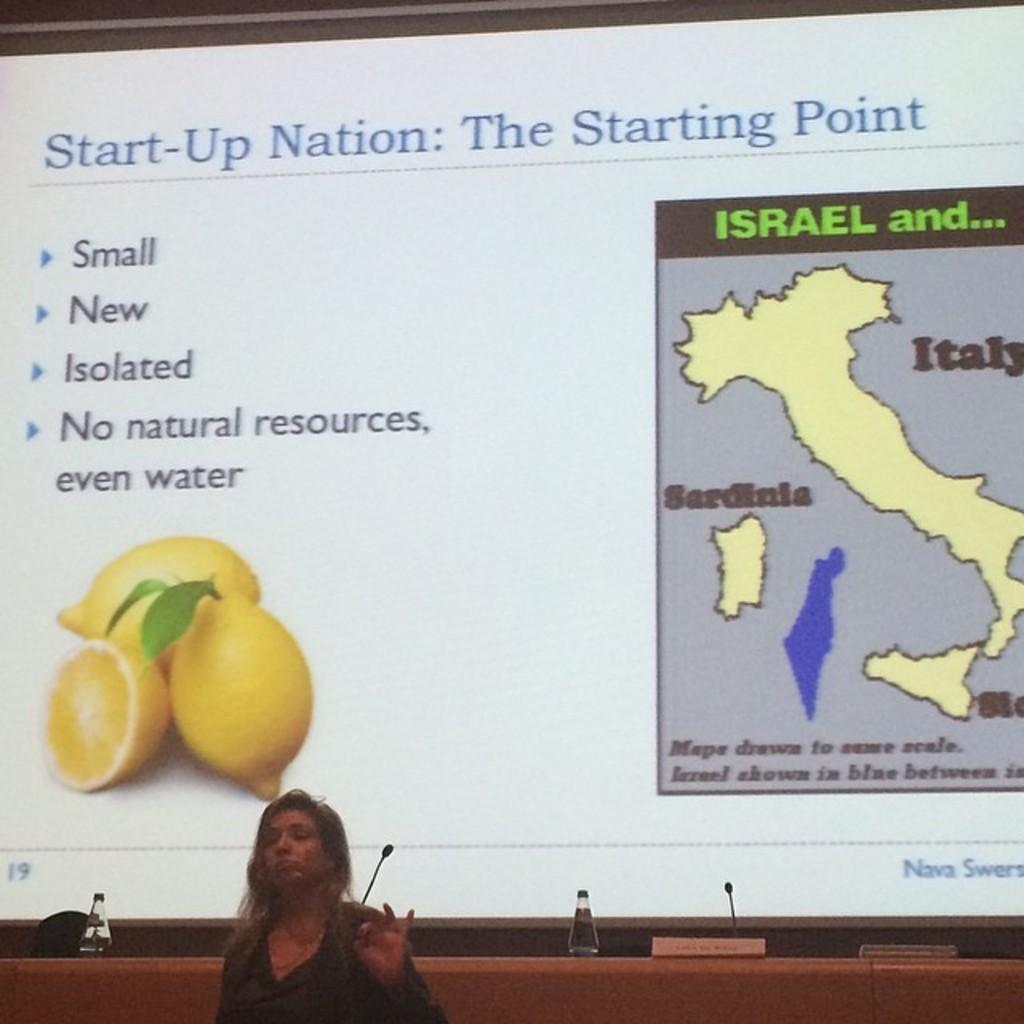Can you describe this image briefly? In the image we can see in front there is a woman standing and behind there is a projector screen on which there are lemon and beside there is a map of italy. 